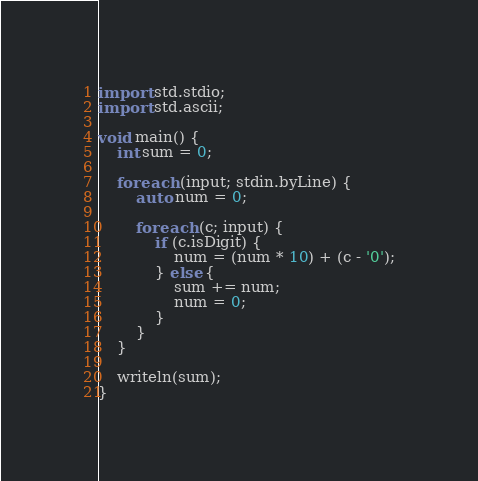<code> <loc_0><loc_0><loc_500><loc_500><_D_>import std.stdio;
import std.ascii;

void main() {
    int sum = 0;

    foreach (input; stdin.byLine) {
        auto num = 0;

        foreach (c; input) {
            if (c.isDigit) {
                num = (num * 10) + (c - '0');
            } else {
                sum += num;
                num = 0;
            }
        }
    }

    writeln(sum);
}</code> 